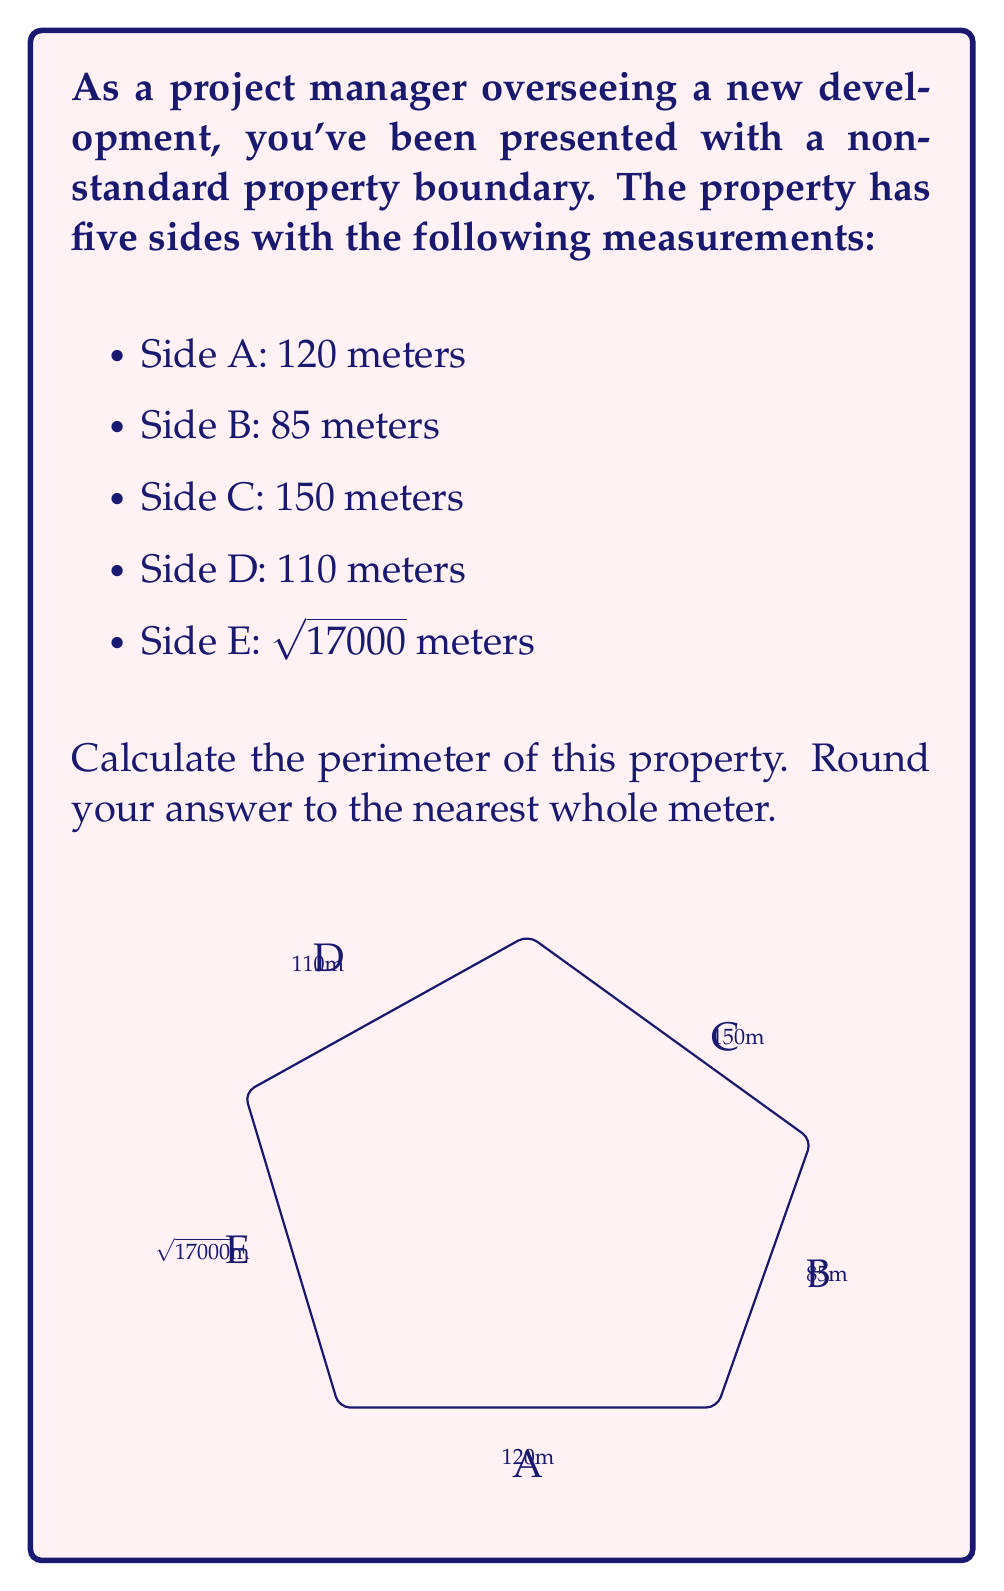What is the answer to this math problem? To calculate the perimeter of the property, we need to add up the lengths of all sides. Let's break this down step-by-step:

1. We have the lengths of sides A, B, C, and D in meters:
   $120 + 85 + 150 + 110 = 465$ meters

2. For side E, we're given $\sqrt{17000}$ meters. Let's calculate this:
   $$\sqrt{17000} \approx 130.3840...$$

3. Now, let's add all sides together:
   $$120 + 85 + 150 + 110 + \sqrt{17000} = 465 + 130.3840...$$

4. This gives us:
   $$595.3840...$$

5. Rounding to the nearest whole meter:
   $$595.3840... \approx 595$$

Therefore, the perimeter of the property is approximately 595 meters.
Answer: 595 meters 